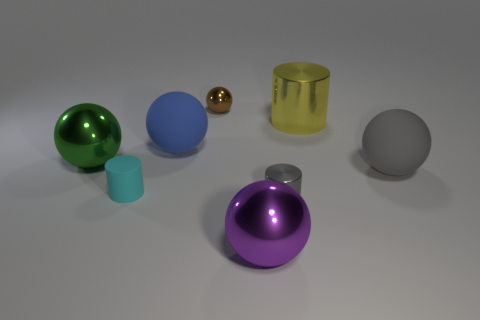Subtract all blue spheres. How many spheres are left? 4 Subtract all small balls. How many balls are left? 4 Subtract all blue balls. Subtract all red cylinders. How many balls are left? 4 Add 1 yellow objects. How many objects exist? 9 Subtract all spheres. How many objects are left? 3 Subtract 0 brown cubes. How many objects are left? 8 Subtract all large purple shiny objects. Subtract all small red shiny cylinders. How many objects are left? 7 Add 4 big blue balls. How many big blue balls are left? 5 Add 7 gray matte objects. How many gray matte objects exist? 8 